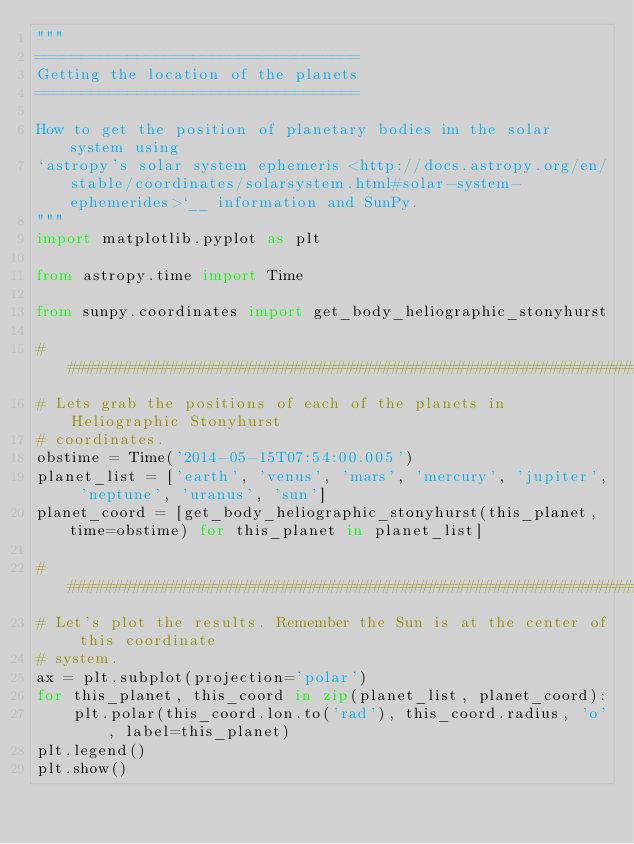Convert code to text. <code><loc_0><loc_0><loc_500><loc_500><_Python_>"""
===================================
Getting the location of the planets
===================================

How to get the position of planetary bodies im the solar system using
`astropy's solar system ephemeris <http://docs.astropy.org/en/stable/coordinates/solarsystem.html#solar-system-ephemerides>`__ information and SunPy.
"""
import matplotlib.pyplot as plt

from astropy.time import Time

from sunpy.coordinates import get_body_heliographic_stonyhurst

##############################################################################
# Lets grab the positions of each of the planets in Heliographic Stonyhurst
# coordinates.
obstime = Time('2014-05-15T07:54:00.005')
planet_list = ['earth', 'venus', 'mars', 'mercury', 'jupiter', 'neptune', 'uranus', 'sun']
planet_coord = [get_body_heliographic_stonyhurst(this_planet, time=obstime) for this_planet in planet_list]

##############################################################################
# Let's plot the results. Remember the Sun is at the center of this coordinate
# system.
ax = plt.subplot(projection='polar')
for this_planet, this_coord in zip(planet_list, planet_coord):
    plt.polar(this_coord.lon.to('rad'), this_coord.radius, 'o', label=this_planet)
plt.legend()
plt.show()
</code> 